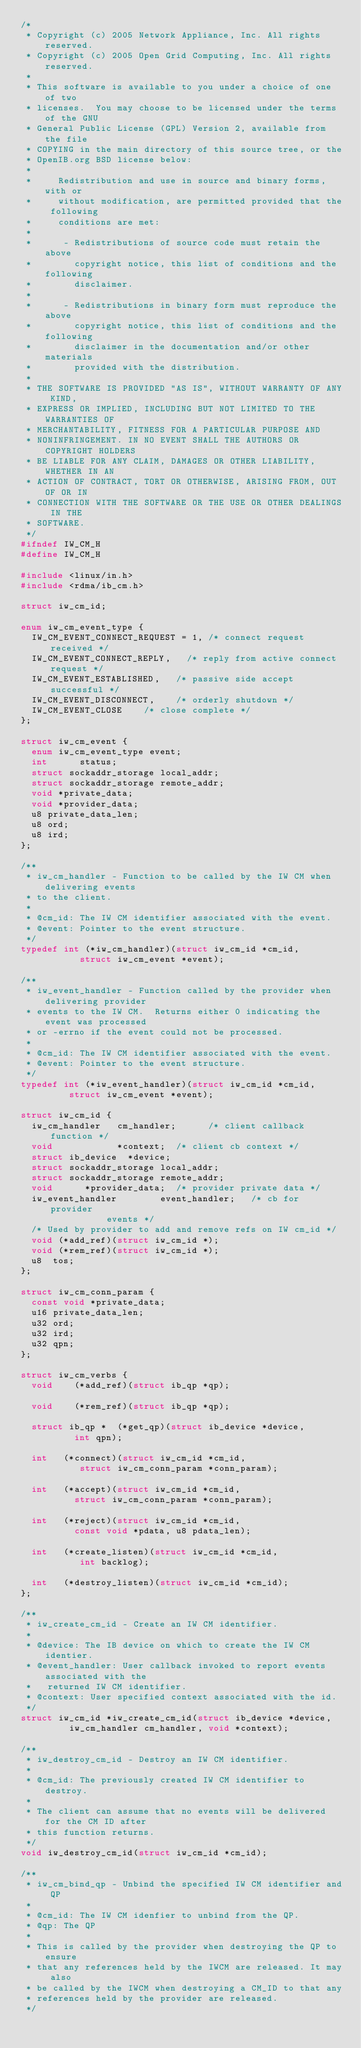Convert code to text. <code><loc_0><loc_0><loc_500><loc_500><_C_>/*
 * Copyright (c) 2005 Network Appliance, Inc. All rights reserved.
 * Copyright (c) 2005 Open Grid Computing, Inc. All rights reserved.
 *
 * This software is available to you under a choice of one of two
 * licenses.  You may choose to be licensed under the terms of the GNU
 * General Public License (GPL) Version 2, available from the file
 * COPYING in the main directory of this source tree, or the
 * OpenIB.org BSD license below:
 *
 *     Redistribution and use in source and binary forms, with or
 *     without modification, are permitted provided that the following
 *     conditions are met:
 *
 *      - Redistributions of source code must retain the above
 *        copyright notice, this list of conditions and the following
 *        disclaimer.
 *
 *      - Redistributions in binary form must reproduce the above
 *        copyright notice, this list of conditions and the following
 *        disclaimer in the documentation and/or other materials
 *        provided with the distribution.
 *
 * THE SOFTWARE IS PROVIDED "AS IS", WITHOUT WARRANTY OF ANY KIND,
 * EXPRESS OR IMPLIED, INCLUDING BUT NOT LIMITED TO THE WARRANTIES OF
 * MERCHANTABILITY, FITNESS FOR A PARTICULAR PURPOSE AND
 * NONINFRINGEMENT. IN NO EVENT SHALL THE AUTHORS OR COPYRIGHT HOLDERS
 * BE LIABLE FOR ANY CLAIM, DAMAGES OR OTHER LIABILITY, WHETHER IN AN
 * ACTION OF CONTRACT, TORT OR OTHERWISE, ARISING FROM, OUT OF OR IN
 * CONNECTION WITH THE SOFTWARE OR THE USE OR OTHER DEALINGS IN THE
 * SOFTWARE.
 */
#ifndef IW_CM_H
#define IW_CM_H

#include <linux/in.h>
#include <rdma/ib_cm.h>

struct iw_cm_id;

enum iw_cm_event_type {
	IW_CM_EVENT_CONNECT_REQUEST = 1, /* connect request received */
	IW_CM_EVENT_CONNECT_REPLY,	 /* reply from active connect request */
	IW_CM_EVENT_ESTABLISHED,	 /* passive side accept successful */
	IW_CM_EVENT_DISCONNECT,		 /* orderly shutdown */
	IW_CM_EVENT_CLOSE		 /* close complete */
};

struct iw_cm_event {
	enum iw_cm_event_type event;
	int			 status;
	struct sockaddr_storage local_addr;
	struct sockaddr_storage remote_addr;
	void *private_data;
	void *provider_data;
	u8 private_data_len;
	u8 ord;
	u8 ird;
};

/**
 * iw_cm_handler - Function to be called by the IW CM when delivering events
 * to the client.
 *
 * @cm_id: The IW CM identifier associated with the event.
 * @event: Pointer to the event structure.
 */
typedef int (*iw_cm_handler)(struct iw_cm_id *cm_id,
			     struct iw_cm_event *event);

/**
 * iw_event_handler - Function called by the provider when delivering provider
 * events to the IW CM.  Returns either 0 indicating the event was processed
 * or -errno if the event could not be processed.
 *
 * @cm_id: The IW CM identifier associated with the event.
 * @event: Pointer to the event structure.
 */
typedef int (*iw_event_handler)(struct iw_cm_id *cm_id,
				 struct iw_cm_event *event);

struct iw_cm_id {
	iw_cm_handler		cm_handler;      /* client callback function */
	void		        *context;	 /* client cb context */
	struct ib_device	*device;
	struct sockaddr_storage local_addr;
	struct sockaddr_storage	remote_addr;
	void			*provider_data;	 /* provider private data */
	iw_event_handler        event_handler;   /* cb for provider
						    events */
	/* Used by provider to add and remove refs on IW cm_id */
	void (*add_ref)(struct iw_cm_id *);
	void (*rem_ref)(struct iw_cm_id *);
	u8  tos;
};

struct iw_cm_conn_param {
	const void *private_data;
	u16 private_data_len;
	u32 ord;
	u32 ird;
	u32 qpn;
};

struct iw_cm_verbs {
	void		(*add_ref)(struct ib_qp *qp);

	void		(*rem_ref)(struct ib_qp *qp);

	struct ib_qp *	(*get_qp)(struct ib_device *device,
				  int qpn);

	int		(*connect)(struct iw_cm_id *cm_id,
				   struct iw_cm_conn_param *conn_param);

	int		(*accept)(struct iw_cm_id *cm_id,
				  struct iw_cm_conn_param *conn_param);

	int		(*reject)(struct iw_cm_id *cm_id,
				  const void *pdata, u8 pdata_len);

	int		(*create_listen)(struct iw_cm_id *cm_id,
					 int backlog);

	int		(*destroy_listen)(struct iw_cm_id *cm_id);
};

/**
 * iw_create_cm_id - Create an IW CM identifier.
 *
 * @device: The IB device on which to create the IW CM identier.
 * @event_handler: User callback invoked to report events associated with the
 *   returned IW CM identifier.
 * @context: User specified context associated with the id.
 */
struct iw_cm_id *iw_create_cm_id(struct ib_device *device,
				 iw_cm_handler cm_handler, void *context);

/**
 * iw_destroy_cm_id - Destroy an IW CM identifier.
 *
 * @cm_id: The previously created IW CM identifier to destroy.
 *
 * The client can assume that no events will be delivered for the CM ID after
 * this function returns.
 */
void iw_destroy_cm_id(struct iw_cm_id *cm_id);

/**
 * iw_cm_bind_qp - Unbind the specified IW CM identifier and QP
 *
 * @cm_id: The IW CM idenfier to unbind from the QP.
 * @qp: The QP
 *
 * This is called by the provider when destroying the QP to ensure
 * that any references held by the IWCM are released. It may also
 * be called by the IWCM when destroying a CM_ID to that any
 * references held by the provider are released.
 */</code> 